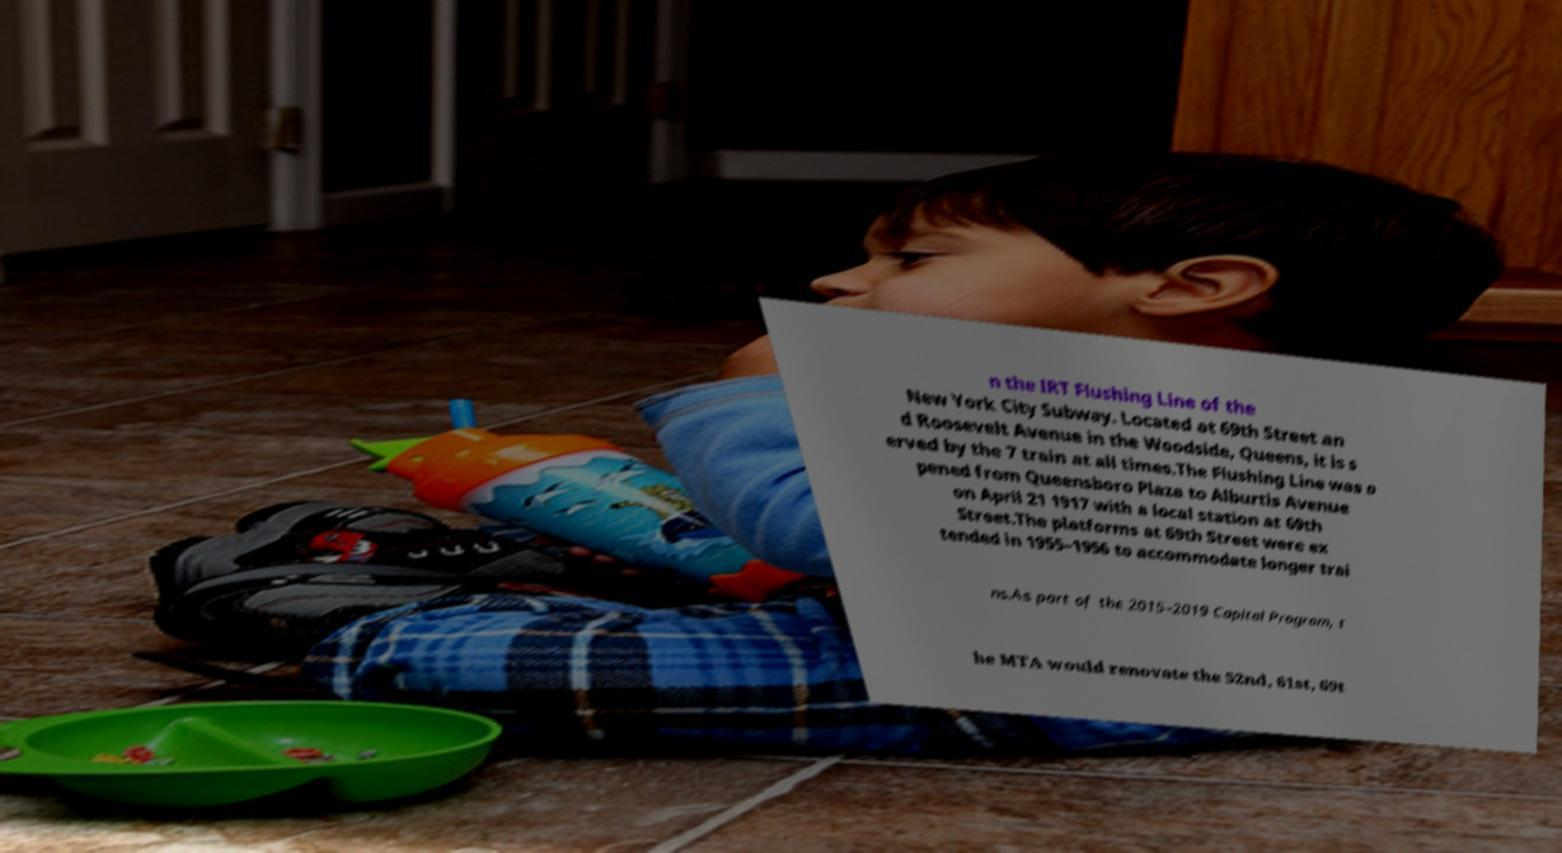There's text embedded in this image that I need extracted. Can you transcribe it verbatim? n the IRT Flushing Line of the New York City Subway. Located at 69th Street an d Roosevelt Avenue in the Woodside, Queens, it is s erved by the 7 train at all times.The Flushing Line was o pened from Queensboro Plaza to Alburtis Avenue on April 21 1917 with a local station at 69th Street.The platforms at 69th Street were ex tended in 1955–1956 to accommodate longer trai ns.As part of the 2015–2019 Capital Program, t he MTA would renovate the 52nd, 61st, 69t 